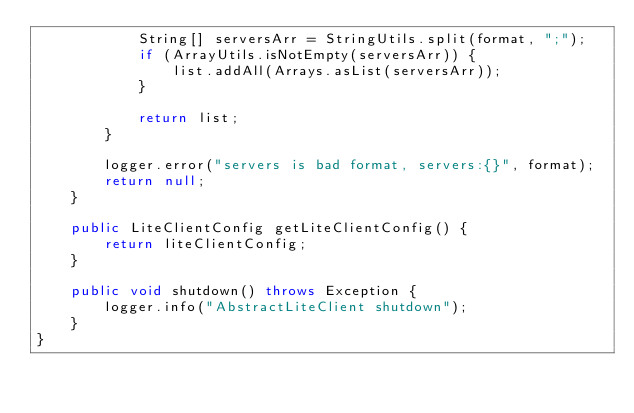Convert code to text. <code><loc_0><loc_0><loc_500><loc_500><_Java_>            String[] serversArr = StringUtils.split(format, ";");
            if (ArrayUtils.isNotEmpty(serversArr)) {
                list.addAll(Arrays.asList(serversArr));
            }

            return list;
        }

        logger.error("servers is bad format, servers:{}", format);
        return null;
    }

    public LiteClientConfig getLiteClientConfig() {
        return liteClientConfig;
    }

    public void shutdown() throws Exception {
        logger.info("AbstractLiteClient shutdown");
    }
}
</code> 